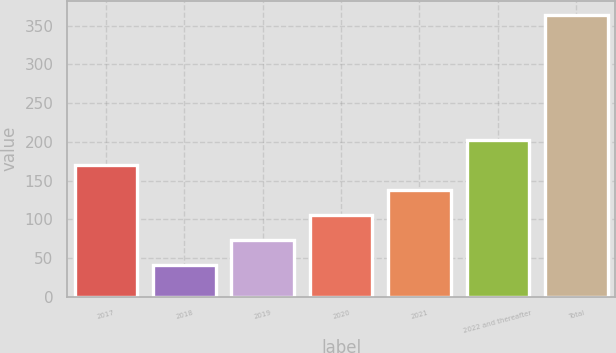Convert chart. <chart><loc_0><loc_0><loc_500><loc_500><bar_chart><fcel>2017<fcel>2018<fcel>2019<fcel>2020<fcel>2021<fcel>2022 and thereafter<fcel>Total<nl><fcel>170.2<fcel>41<fcel>73.3<fcel>105.6<fcel>137.9<fcel>202.5<fcel>364<nl></chart> 